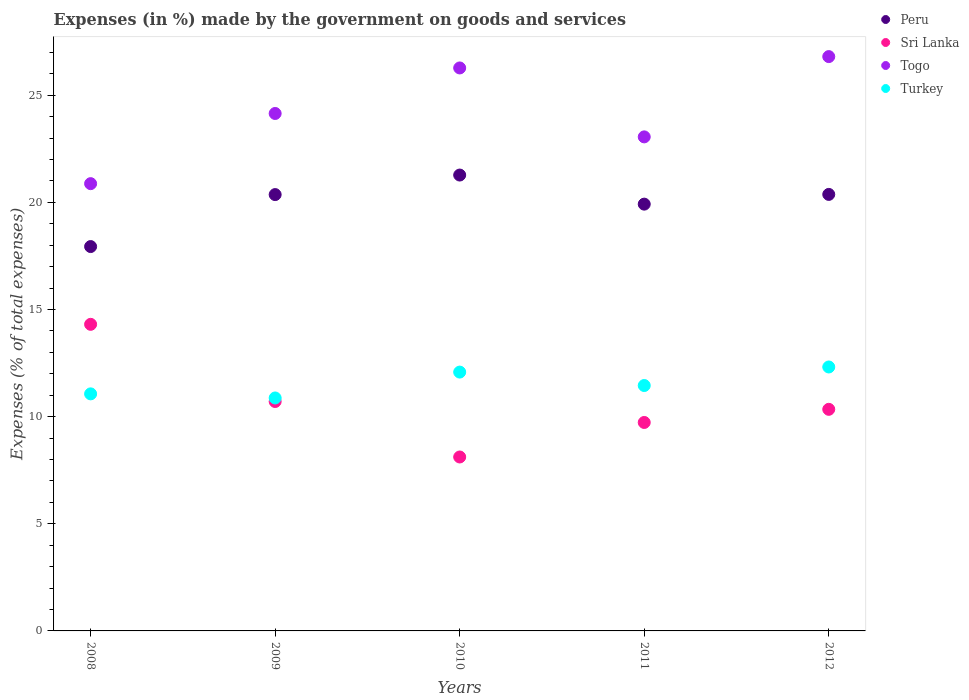What is the percentage of expenses made by the government on goods and services in Sri Lanka in 2009?
Keep it short and to the point. 10.71. Across all years, what is the maximum percentage of expenses made by the government on goods and services in Turkey?
Offer a terse response. 12.32. Across all years, what is the minimum percentage of expenses made by the government on goods and services in Turkey?
Keep it short and to the point. 10.87. In which year was the percentage of expenses made by the government on goods and services in Turkey minimum?
Ensure brevity in your answer.  2009. What is the total percentage of expenses made by the government on goods and services in Turkey in the graph?
Offer a very short reply. 57.79. What is the difference between the percentage of expenses made by the government on goods and services in Peru in 2010 and that in 2011?
Your response must be concise. 1.36. What is the difference between the percentage of expenses made by the government on goods and services in Togo in 2008 and the percentage of expenses made by the government on goods and services in Peru in 2009?
Provide a short and direct response. 0.51. What is the average percentage of expenses made by the government on goods and services in Sri Lanka per year?
Offer a very short reply. 10.64. In the year 2012, what is the difference between the percentage of expenses made by the government on goods and services in Sri Lanka and percentage of expenses made by the government on goods and services in Peru?
Provide a short and direct response. -10.03. In how many years, is the percentage of expenses made by the government on goods and services in Sri Lanka greater than 4 %?
Offer a very short reply. 5. What is the ratio of the percentage of expenses made by the government on goods and services in Turkey in 2009 to that in 2010?
Your response must be concise. 0.9. Is the percentage of expenses made by the government on goods and services in Peru in 2008 less than that in 2011?
Offer a very short reply. Yes. Is the difference between the percentage of expenses made by the government on goods and services in Sri Lanka in 2010 and 2011 greater than the difference between the percentage of expenses made by the government on goods and services in Peru in 2010 and 2011?
Provide a short and direct response. No. What is the difference between the highest and the second highest percentage of expenses made by the government on goods and services in Togo?
Offer a very short reply. 0.53. What is the difference between the highest and the lowest percentage of expenses made by the government on goods and services in Peru?
Your response must be concise. 3.34. Is it the case that in every year, the sum of the percentage of expenses made by the government on goods and services in Togo and percentage of expenses made by the government on goods and services in Peru  is greater than the sum of percentage of expenses made by the government on goods and services in Turkey and percentage of expenses made by the government on goods and services in Sri Lanka?
Your answer should be compact. No. Is the percentage of expenses made by the government on goods and services in Togo strictly greater than the percentage of expenses made by the government on goods and services in Turkey over the years?
Make the answer very short. Yes. How many years are there in the graph?
Your answer should be very brief. 5. How are the legend labels stacked?
Provide a succinct answer. Vertical. What is the title of the graph?
Provide a succinct answer. Expenses (in %) made by the government on goods and services. What is the label or title of the Y-axis?
Give a very brief answer. Expenses (% of total expenses). What is the Expenses (% of total expenses) of Peru in 2008?
Your answer should be very brief. 17.94. What is the Expenses (% of total expenses) in Sri Lanka in 2008?
Give a very brief answer. 14.31. What is the Expenses (% of total expenses) in Togo in 2008?
Keep it short and to the point. 20.87. What is the Expenses (% of total expenses) of Turkey in 2008?
Provide a succinct answer. 11.06. What is the Expenses (% of total expenses) in Peru in 2009?
Make the answer very short. 20.36. What is the Expenses (% of total expenses) in Sri Lanka in 2009?
Keep it short and to the point. 10.71. What is the Expenses (% of total expenses) of Togo in 2009?
Give a very brief answer. 24.15. What is the Expenses (% of total expenses) in Turkey in 2009?
Your response must be concise. 10.87. What is the Expenses (% of total expenses) of Peru in 2010?
Keep it short and to the point. 21.28. What is the Expenses (% of total expenses) in Sri Lanka in 2010?
Provide a succinct answer. 8.12. What is the Expenses (% of total expenses) of Togo in 2010?
Ensure brevity in your answer.  26.27. What is the Expenses (% of total expenses) of Turkey in 2010?
Provide a succinct answer. 12.08. What is the Expenses (% of total expenses) of Peru in 2011?
Your response must be concise. 19.92. What is the Expenses (% of total expenses) in Sri Lanka in 2011?
Keep it short and to the point. 9.73. What is the Expenses (% of total expenses) of Togo in 2011?
Make the answer very short. 23.06. What is the Expenses (% of total expenses) of Turkey in 2011?
Give a very brief answer. 11.45. What is the Expenses (% of total expenses) of Peru in 2012?
Keep it short and to the point. 20.37. What is the Expenses (% of total expenses) in Sri Lanka in 2012?
Provide a succinct answer. 10.34. What is the Expenses (% of total expenses) in Togo in 2012?
Your answer should be very brief. 26.8. What is the Expenses (% of total expenses) of Turkey in 2012?
Your answer should be very brief. 12.32. Across all years, what is the maximum Expenses (% of total expenses) of Peru?
Provide a short and direct response. 21.28. Across all years, what is the maximum Expenses (% of total expenses) in Sri Lanka?
Keep it short and to the point. 14.31. Across all years, what is the maximum Expenses (% of total expenses) in Togo?
Provide a short and direct response. 26.8. Across all years, what is the maximum Expenses (% of total expenses) in Turkey?
Offer a very short reply. 12.32. Across all years, what is the minimum Expenses (% of total expenses) in Peru?
Your answer should be very brief. 17.94. Across all years, what is the minimum Expenses (% of total expenses) of Sri Lanka?
Your response must be concise. 8.12. Across all years, what is the minimum Expenses (% of total expenses) in Togo?
Give a very brief answer. 20.87. Across all years, what is the minimum Expenses (% of total expenses) of Turkey?
Make the answer very short. 10.87. What is the total Expenses (% of total expenses) in Peru in the graph?
Your response must be concise. 99.87. What is the total Expenses (% of total expenses) in Sri Lanka in the graph?
Your answer should be very brief. 53.2. What is the total Expenses (% of total expenses) of Togo in the graph?
Provide a short and direct response. 121.16. What is the total Expenses (% of total expenses) in Turkey in the graph?
Ensure brevity in your answer.  57.79. What is the difference between the Expenses (% of total expenses) of Peru in 2008 and that in 2009?
Give a very brief answer. -2.43. What is the difference between the Expenses (% of total expenses) of Sri Lanka in 2008 and that in 2009?
Your answer should be compact. 3.6. What is the difference between the Expenses (% of total expenses) in Togo in 2008 and that in 2009?
Keep it short and to the point. -3.28. What is the difference between the Expenses (% of total expenses) in Turkey in 2008 and that in 2009?
Keep it short and to the point. 0.19. What is the difference between the Expenses (% of total expenses) of Peru in 2008 and that in 2010?
Offer a very short reply. -3.34. What is the difference between the Expenses (% of total expenses) in Sri Lanka in 2008 and that in 2010?
Offer a terse response. 6.19. What is the difference between the Expenses (% of total expenses) of Togo in 2008 and that in 2010?
Provide a succinct answer. -5.4. What is the difference between the Expenses (% of total expenses) in Turkey in 2008 and that in 2010?
Your response must be concise. -1.02. What is the difference between the Expenses (% of total expenses) of Peru in 2008 and that in 2011?
Give a very brief answer. -1.98. What is the difference between the Expenses (% of total expenses) in Sri Lanka in 2008 and that in 2011?
Provide a short and direct response. 4.58. What is the difference between the Expenses (% of total expenses) in Togo in 2008 and that in 2011?
Keep it short and to the point. -2.18. What is the difference between the Expenses (% of total expenses) in Turkey in 2008 and that in 2011?
Give a very brief answer. -0.39. What is the difference between the Expenses (% of total expenses) of Peru in 2008 and that in 2012?
Your response must be concise. -2.43. What is the difference between the Expenses (% of total expenses) in Sri Lanka in 2008 and that in 2012?
Provide a short and direct response. 3.97. What is the difference between the Expenses (% of total expenses) of Togo in 2008 and that in 2012?
Provide a short and direct response. -5.93. What is the difference between the Expenses (% of total expenses) in Turkey in 2008 and that in 2012?
Offer a terse response. -1.25. What is the difference between the Expenses (% of total expenses) in Peru in 2009 and that in 2010?
Provide a succinct answer. -0.91. What is the difference between the Expenses (% of total expenses) of Sri Lanka in 2009 and that in 2010?
Make the answer very short. 2.59. What is the difference between the Expenses (% of total expenses) in Togo in 2009 and that in 2010?
Offer a very short reply. -2.12. What is the difference between the Expenses (% of total expenses) in Turkey in 2009 and that in 2010?
Your response must be concise. -1.21. What is the difference between the Expenses (% of total expenses) of Peru in 2009 and that in 2011?
Provide a short and direct response. 0.45. What is the difference between the Expenses (% of total expenses) in Sri Lanka in 2009 and that in 2011?
Provide a short and direct response. 0.98. What is the difference between the Expenses (% of total expenses) in Togo in 2009 and that in 2011?
Keep it short and to the point. 1.09. What is the difference between the Expenses (% of total expenses) in Turkey in 2009 and that in 2011?
Give a very brief answer. -0.58. What is the difference between the Expenses (% of total expenses) in Peru in 2009 and that in 2012?
Your response must be concise. -0.01. What is the difference between the Expenses (% of total expenses) of Sri Lanka in 2009 and that in 2012?
Keep it short and to the point. 0.36. What is the difference between the Expenses (% of total expenses) in Togo in 2009 and that in 2012?
Provide a succinct answer. -2.65. What is the difference between the Expenses (% of total expenses) in Turkey in 2009 and that in 2012?
Ensure brevity in your answer.  -1.45. What is the difference between the Expenses (% of total expenses) of Peru in 2010 and that in 2011?
Offer a terse response. 1.36. What is the difference between the Expenses (% of total expenses) of Sri Lanka in 2010 and that in 2011?
Keep it short and to the point. -1.61. What is the difference between the Expenses (% of total expenses) of Togo in 2010 and that in 2011?
Make the answer very short. 3.22. What is the difference between the Expenses (% of total expenses) of Turkey in 2010 and that in 2011?
Make the answer very short. 0.63. What is the difference between the Expenses (% of total expenses) of Peru in 2010 and that in 2012?
Keep it short and to the point. 0.9. What is the difference between the Expenses (% of total expenses) in Sri Lanka in 2010 and that in 2012?
Provide a succinct answer. -2.22. What is the difference between the Expenses (% of total expenses) of Togo in 2010 and that in 2012?
Offer a very short reply. -0.53. What is the difference between the Expenses (% of total expenses) in Turkey in 2010 and that in 2012?
Provide a succinct answer. -0.24. What is the difference between the Expenses (% of total expenses) in Peru in 2011 and that in 2012?
Offer a very short reply. -0.45. What is the difference between the Expenses (% of total expenses) in Sri Lanka in 2011 and that in 2012?
Your response must be concise. -0.61. What is the difference between the Expenses (% of total expenses) of Togo in 2011 and that in 2012?
Your answer should be compact. -3.75. What is the difference between the Expenses (% of total expenses) in Turkey in 2011 and that in 2012?
Give a very brief answer. -0.87. What is the difference between the Expenses (% of total expenses) of Peru in 2008 and the Expenses (% of total expenses) of Sri Lanka in 2009?
Keep it short and to the point. 7.23. What is the difference between the Expenses (% of total expenses) in Peru in 2008 and the Expenses (% of total expenses) in Togo in 2009?
Your response must be concise. -6.21. What is the difference between the Expenses (% of total expenses) in Peru in 2008 and the Expenses (% of total expenses) in Turkey in 2009?
Provide a succinct answer. 7.07. What is the difference between the Expenses (% of total expenses) in Sri Lanka in 2008 and the Expenses (% of total expenses) in Togo in 2009?
Give a very brief answer. -9.84. What is the difference between the Expenses (% of total expenses) of Sri Lanka in 2008 and the Expenses (% of total expenses) of Turkey in 2009?
Provide a short and direct response. 3.44. What is the difference between the Expenses (% of total expenses) in Togo in 2008 and the Expenses (% of total expenses) in Turkey in 2009?
Offer a very short reply. 10. What is the difference between the Expenses (% of total expenses) of Peru in 2008 and the Expenses (% of total expenses) of Sri Lanka in 2010?
Ensure brevity in your answer.  9.82. What is the difference between the Expenses (% of total expenses) of Peru in 2008 and the Expenses (% of total expenses) of Togo in 2010?
Your response must be concise. -8.34. What is the difference between the Expenses (% of total expenses) in Peru in 2008 and the Expenses (% of total expenses) in Turkey in 2010?
Your response must be concise. 5.86. What is the difference between the Expenses (% of total expenses) of Sri Lanka in 2008 and the Expenses (% of total expenses) of Togo in 2010?
Your answer should be very brief. -11.97. What is the difference between the Expenses (% of total expenses) of Sri Lanka in 2008 and the Expenses (% of total expenses) of Turkey in 2010?
Offer a very short reply. 2.23. What is the difference between the Expenses (% of total expenses) of Togo in 2008 and the Expenses (% of total expenses) of Turkey in 2010?
Your answer should be very brief. 8.79. What is the difference between the Expenses (% of total expenses) in Peru in 2008 and the Expenses (% of total expenses) in Sri Lanka in 2011?
Your answer should be compact. 8.21. What is the difference between the Expenses (% of total expenses) in Peru in 2008 and the Expenses (% of total expenses) in Togo in 2011?
Your response must be concise. -5.12. What is the difference between the Expenses (% of total expenses) of Peru in 2008 and the Expenses (% of total expenses) of Turkey in 2011?
Your answer should be very brief. 6.49. What is the difference between the Expenses (% of total expenses) in Sri Lanka in 2008 and the Expenses (% of total expenses) in Togo in 2011?
Give a very brief answer. -8.75. What is the difference between the Expenses (% of total expenses) in Sri Lanka in 2008 and the Expenses (% of total expenses) in Turkey in 2011?
Make the answer very short. 2.86. What is the difference between the Expenses (% of total expenses) of Togo in 2008 and the Expenses (% of total expenses) of Turkey in 2011?
Give a very brief answer. 9.42. What is the difference between the Expenses (% of total expenses) of Peru in 2008 and the Expenses (% of total expenses) of Sri Lanka in 2012?
Your answer should be very brief. 7.6. What is the difference between the Expenses (% of total expenses) of Peru in 2008 and the Expenses (% of total expenses) of Togo in 2012?
Provide a short and direct response. -8.87. What is the difference between the Expenses (% of total expenses) in Peru in 2008 and the Expenses (% of total expenses) in Turkey in 2012?
Ensure brevity in your answer.  5.62. What is the difference between the Expenses (% of total expenses) of Sri Lanka in 2008 and the Expenses (% of total expenses) of Togo in 2012?
Your response must be concise. -12.5. What is the difference between the Expenses (% of total expenses) in Sri Lanka in 2008 and the Expenses (% of total expenses) in Turkey in 2012?
Give a very brief answer. 1.99. What is the difference between the Expenses (% of total expenses) of Togo in 2008 and the Expenses (% of total expenses) of Turkey in 2012?
Your response must be concise. 8.56. What is the difference between the Expenses (% of total expenses) in Peru in 2009 and the Expenses (% of total expenses) in Sri Lanka in 2010?
Ensure brevity in your answer.  12.25. What is the difference between the Expenses (% of total expenses) of Peru in 2009 and the Expenses (% of total expenses) of Togo in 2010?
Give a very brief answer. -5.91. What is the difference between the Expenses (% of total expenses) of Peru in 2009 and the Expenses (% of total expenses) of Turkey in 2010?
Your answer should be compact. 8.28. What is the difference between the Expenses (% of total expenses) of Sri Lanka in 2009 and the Expenses (% of total expenses) of Togo in 2010?
Your response must be concise. -15.57. What is the difference between the Expenses (% of total expenses) of Sri Lanka in 2009 and the Expenses (% of total expenses) of Turkey in 2010?
Give a very brief answer. -1.37. What is the difference between the Expenses (% of total expenses) in Togo in 2009 and the Expenses (% of total expenses) in Turkey in 2010?
Your answer should be compact. 12.07. What is the difference between the Expenses (% of total expenses) of Peru in 2009 and the Expenses (% of total expenses) of Sri Lanka in 2011?
Ensure brevity in your answer.  10.64. What is the difference between the Expenses (% of total expenses) of Peru in 2009 and the Expenses (% of total expenses) of Togo in 2011?
Your response must be concise. -2.69. What is the difference between the Expenses (% of total expenses) in Peru in 2009 and the Expenses (% of total expenses) in Turkey in 2011?
Keep it short and to the point. 8.91. What is the difference between the Expenses (% of total expenses) of Sri Lanka in 2009 and the Expenses (% of total expenses) of Togo in 2011?
Provide a short and direct response. -12.35. What is the difference between the Expenses (% of total expenses) in Sri Lanka in 2009 and the Expenses (% of total expenses) in Turkey in 2011?
Offer a terse response. -0.75. What is the difference between the Expenses (% of total expenses) of Togo in 2009 and the Expenses (% of total expenses) of Turkey in 2011?
Make the answer very short. 12.7. What is the difference between the Expenses (% of total expenses) in Peru in 2009 and the Expenses (% of total expenses) in Sri Lanka in 2012?
Give a very brief answer. 10.02. What is the difference between the Expenses (% of total expenses) of Peru in 2009 and the Expenses (% of total expenses) of Togo in 2012?
Make the answer very short. -6.44. What is the difference between the Expenses (% of total expenses) in Peru in 2009 and the Expenses (% of total expenses) in Turkey in 2012?
Make the answer very short. 8.05. What is the difference between the Expenses (% of total expenses) of Sri Lanka in 2009 and the Expenses (% of total expenses) of Togo in 2012?
Make the answer very short. -16.1. What is the difference between the Expenses (% of total expenses) of Sri Lanka in 2009 and the Expenses (% of total expenses) of Turkey in 2012?
Make the answer very short. -1.61. What is the difference between the Expenses (% of total expenses) of Togo in 2009 and the Expenses (% of total expenses) of Turkey in 2012?
Provide a short and direct response. 11.83. What is the difference between the Expenses (% of total expenses) in Peru in 2010 and the Expenses (% of total expenses) in Sri Lanka in 2011?
Offer a terse response. 11.55. What is the difference between the Expenses (% of total expenses) of Peru in 2010 and the Expenses (% of total expenses) of Togo in 2011?
Offer a very short reply. -1.78. What is the difference between the Expenses (% of total expenses) of Peru in 2010 and the Expenses (% of total expenses) of Turkey in 2011?
Your answer should be very brief. 9.82. What is the difference between the Expenses (% of total expenses) in Sri Lanka in 2010 and the Expenses (% of total expenses) in Togo in 2011?
Provide a short and direct response. -14.94. What is the difference between the Expenses (% of total expenses) in Sri Lanka in 2010 and the Expenses (% of total expenses) in Turkey in 2011?
Provide a succinct answer. -3.34. What is the difference between the Expenses (% of total expenses) of Togo in 2010 and the Expenses (% of total expenses) of Turkey in 2011?
Give a very brief answer. 14.82. What is the difference between the Expenses (% of total expenses) of Peru in 2010 and the Expenses (% of total expenses) of Sri Lanka in 2012?
Your answer should be very brief. 10.93. What is the difference between the Expenses (% of total expenses) in Peru in 2010 and the Expenses (% of total expenses) in Togo in 2012?
Offer a terse response. -5.53. What is the difference between the Expenses (% of total expenses) of Peru in 2010 and the Expenses (% of total expenses) of Turkey in 2012?
Ensure brevity in your answer.  8.96. What is the difference between the Expenses (% of total expenses) in Sri Lanka in 2010 and the Expenses (% of total expenses) in Togo in 2012?
Your answer should be very brief. -18.69. What is the difference between the Expenses (% of total expenses) in Sri Lanka in 2010 and the Expenses (% of total expenses) in Turkey in 2012?
Provide a short and direct response. -4.2. What is the difference between the Expenses (% of total expenses) in Togo in 2010 and the Expenses (% of total expenses) in Turkey in 2012?
Your response must be concise. 13.96. What is the difference between the Expenses (% of total expenses) in Peru in 2011 and the Expenses (% of total expenses) in Sri Lanka in 2012?
Your answer should be very brief. 9.58. What is the difference between the Expenses (% of total expenses) in Peru in 2011 and the Expenses (% of total expenses) in Togo in 2012?
Provide a short and direct response. -6.89. What is the difference between the Expenses (% of total expenses) of Sri Lanka in 2011 and the Expenses (% of total expenses) of Togo in 2012?
Keep it short and to the point. -17.08. What is the difference between the Expenses (% of total expenses) in Sri Lanka in 2011 and the Expenses (% of total expenses) in Turkey in 2012?
Your answer should be compact. -2.59. What is the difference between the Expenses (% of total expenses) of Togo in 2011 and the Expenses (% of total expenses) of Turkey in 2012?
Your answer should be very brief. 10.74. What is the average Expenses (% of total expenses) in Peru per year?
Your answer should be compact. 19.97. What is the average Expenses (% of total expenses) in Sri Lanka per year?
Offer a very short reply. 10.64. What is the average Expenses (% of total expenses) of Togo per year?
Make the answer very short. 24.23. What is the average Expenses (% of total expenses) in Turkey per year?
Your answer should be very brief. 11.56. In the year 2008, what is the difference between the Expenses (% of total expenses) in Peru and Expenses (% of total expenses) in Sri Lanka?
Your answer should be very brief. 3.63. In the year 2008, what is the difference between the Expenses (% of total expenses) in Peru and Expenses (% of total expenses) in Togo?
Keep it short and to the point. -2.94. In the year 2008, what is the difference between the Expenses (% of total expenses) in Peru and Expenses (% of total expenses) in Turkey?
Offer a terse response. 6.87. In the year 2008, what is the difference between the Expenses (% of total expenses) in Sri Lanka and Expenses (% of total expenses) in Togo?
Provide a succinct answer. -6.57. In the year 2008, what is the difference between the Expenses (% of total expenses) in Sri Lanka and Expenses (% of total expenses) in Turkey?
Offer a terse response. 3.25. In the year 2008, what is the difference between the Expenses (% of total expenses) in Togo and Expenses (% of total expenses) in Turkey?
Offer a very short reply. 9.81. In the year 2009, what is the difference between the Expenses (% of total expenses) of Peru and Expenses (% of total expenses) of Sri Lanka?
Provide a succinct answer. 9.66. In the year 2009, what is the difference between the Expenses (% of total expenses) in Peru and Expenses (% of total expenses) in Togo?
Your answer should be very brief. -3.79. In the year 2009, what is the difference between the Expenses (% of total expenses) in Peru and Expenses (% of total expenses) in Turkey?
Ensure brevity in your answer.  9.49. In the year 2009, what is the difference between the Expenses (% of total expenses) of Sri Lanka and Expenses (% of total expenses) of Togo?
Provide a short and direct response. -13.44. In the year 2009, what is the difference between the Expenses (% of total expenses) in Sri Lanka and Expenses (% of total expenses) in Turkey?
Your response must be concise. -0.17. In the year 2009, what is the difference between the Expenses (% of total expenses) of Togo and Expenses (% of total expenses) of Turkey?
Give a very brief answer. 13.28. In the year 2010, what is the difference between the Expenses (% of total expenses) in Peru and Expenses (% of total expenses) in Sri Lanka?
Provide a succinct answer. 13.16. In the year 2010, what is the difference between the Expenses (% of total expenses) of Peru and Expenses (% of total expenses) of Togo?
Your answer should be compact. -5. In the year 2010, what is the difference between the Expenses (% of total expenses) in Peru and Expenses (% of total expenses) in Turkey?
Your response must be concise. 9.2. In the year 2010, what is the difference between the Expenses (% of total expenses) of Sri Lanka and Expenses (% of total expenses) of Togo?
Offer a terse response. -18.16. In the year 2010, what is the difference between the Expenses (% of total expenses) in Sri Lanka and Expenses (% of total expenses) in Turkey?
Provide a short and direct response. -3.96. In the year 2010, what is the difference between the Expenses (% of total expenses) in Togo and Expenses (% of total expenses) in Turkey?
Your response must be concise. 14.19. In the year 2011, what is the difference between the Expenses (% of total expenses) of Peru and Expenses (% of total expenses) of Sri Lanka?
Make the answer very short. 10.19. In the year 2011, what is the difference between the Expenses (% of total expenses) in Peru and Expenses (% of total expenses) in Togo?
Give a very brief answer. -3.14. In the year 2011, what is the difference between the Expenses (% of total expenses) in Peru and Expenses (% of total expenses) in Turkey?
Make the answer very short. 8.47. In the year 2011, what is the difference between the Expenses (% of total expenses) of Sri Lanka and Expenses (% of total expenses) of Togo?
Keep it short and to the point. -13.33. In the year 2011, what is the difference between the Expenses (% of total expenses) of Sri Lanka and Expenses (% of total expenses) of Turkey?
Offer a terse response. -1.72. In the year 2011, what is the difference between the Expenses (% of total expenses) in Togo and Expenses (% of total expenses) in Turkey?
Offer a very short reply. 11.6. In the year 2012, what is the difference between the Expenses (% of total expenses) in Peru and Expenses (% of total expenses) in Sri Lanka?
Make the answer very short. 10.03. In the year 2012, what is the difference between the Expenses (% of total expenses) in Peru and Expenses (% of total expenses) in Togo?
Give a very brief answer. -6.43. In the year 2012, what is the difference between the Expenses (% of total expenses) in Peru and Expenses (% of total expenses) in Turkey?
Offer a terse response. 8.05. In the year 2012, what is the difference between the Expenses (% of total expenses) in Sri Lanka and Expenses (% of total expenses) in Togo?
Offer a terse response. -16.46. In the year 2012, what is the difference between the Expenses (% of total expenses) in Sri Lanka and Expenses (% of total expenses) in Turkey?
Provide a short and direct response. -1.98. In the year 2012, what is the difference between the Expenses (% of total expenses) in Togo and Expenses (% of total expenses) in Turkey?
Offer a terse response. 14.49. What is the ratio of the Expenses (% of total expenses) of Peru in 2008 to that in 2009?
Provide a short and direct response. 0.88. What is the ratio of the Expenses (% of total expenses) in Sri Lanka in 2008 to that in 2009?
Your answer should be compact. 1.34. What is the ratio of the Expenses (% of total expenses) in Togo in 2008 to that in 2009?
Provide a short and direct response. 0.86. What is the ratio of the Expenses (% of total expenses) in Turkey in 2008 to that in 2009?
Give a very brief answer. 1.02. What is the ratio of the Expenses (% of total expenses) of Peru in 2008 to that in 2010?
Provide a short and direct response. 0.84. What is the ratio of the Expenses (% of total expenses) in Sri Lanka in 2008 to that in 2010?
Offer a terse response. 1.76. What is the ratio of the Expenses (% of total expenses) of Togo in 2008 to that in 2010?
Ensure brevity in your answer.  0.79. What is the ratio of the Expenses (% of total expenses) in Turkey in 2008 to that in 2010?
Keep it short and to the point. 0.92. What is the ratio of the Expenses (% of total expenses) of Peru in 2008 to that in 2011?
Your answer should be compact. 0.9. What is the ratio of the Expenses (% of total expenses) in Sri Lanka in 2008 to that in 2011?
Offer a terse response. 1.47. What is the ratio of the Expenses (% of total expenses) in Togo in 2008 to that in 2011?
Your answer should be compact. 0.91. What is the ratio of the Expenses (% of total expenses) of Peru in 2008 to that in 2012?
Your answer should be very brief. 0.88. What is the ratio of the Expenses (% of total expenses) of Sri Lanka in 2008 to that in 2012?
Make the answer very short. 1.38. What is the ratio of the Expenses (% of total expenses) in Togo in 2008 to that in 2012?
Your response must be concise. 0.78. What is the ratio of the Expenses (% of total expenses) in Turkey in 2008 to that in 2012?
Keep it short and to the point. 0.9. What is the ratio of the Expenses (% of total expenses) in Peru in 2009 to that in 2010?
Provide a short and direct response. 0.96. What is the ratio of the Expenses (% of total expenses) in Sri Lanka in 2009 to that in 2010?
Offer a very short reply. 1.32. What is the ratio of the Expenses (% of total expenses) in Togo in 2009 to that in 2010?
Offer a terse response. 0.92. What is the ratio of the Expenses (% of total expenses) of Turkey in 2009 to that in 2010?
Keep it short and to the point. 0.9. What is the ratio of the Expenses (% of total expenses) of Peru in 2009 to that in 2011?
Keep it short and to the point. 1.02. What is the ratio of the Expenses (% of total expenses) in Sri Lanka in 2009 to that in 2011?
Provide a succinct answer. 1.1. What is the ratio of the Expenses (% of total expenses) of Togo in 2009 to that in 2011?
Provide a succinct answer. 1.05. What is the ratio of the Expenses (% of total expenses) in Turkey in 2009 to that in 2011?
Your answer should be very brief. 0.95. What is the ratio of the Expenses (% of total expenses) of Peru in 2009 to that in 2012?
Ensure brevity in your answer.  1. What is the ratio of the Expenses (% of total expenses) of Sri Lanka in 2009 to that in 2012?
Provide a succinct answer. 1.04. What is the ratio of the Expenses (% of total expenses) in Togo in 2009 to that in 2012?
Ensure brevity in your answer.  0.9. What is the ratio of the Expenses (% of total expenses) of Turkey in 2009 to that in 2012?
Make the answer very short. 0.88. What is the ratio of the Expenses (% of total expenses) of Peru in 2010 to that in 2011?
Ensure brevity in your answer.  1.07. What is the ratio of the Expenses (% of total expenses) of Sri Lanka in 2010 to that in 2011?
Your answer should be very brief. 0.83. What is the ratio of the Expenses (% of total expenses) in Togo in 2010 to that in 2011?
Keep it short and to the point. 1.14. What is the ratio of the Expenses (% of total expenses) in Turkey in 2010 to that in 2011?
Keep it short and to the point. 1.05. What is the ratio of the Expenses (% of total expenses) in Peru in 2010 to that in 2012?
Ensure brevity in your answer.  1.04. What is the ratio of the Expenses (% of total expenses) of Sri Lanka in 2010 to that in 2012?
Offer a terse response. 0.78. What is the ratio of the Expenses (% of total expenses) in Togo in 2010 to that in 2012?
Provide a short and direct response. 0.98. What is the ratio of the Expenses (% of total expenses) of Turkey in 2010 to that in 2012?
Keep it short and to the point. 0.98. What is the ratio of the Expenses (% of total expenses) in Peru in 2011 to that in 2012?
Offer a terse response. 0.98. What is the ratio of the Expenses (% of total expenses) in Sri Lanka in 2011 to that in 2012?
Offer a terse response. 0.94. What is the ratio of the Expenses (% of total expenses) of Togo in 2011 to that in 2012?
Provide a succinct answer. 0.86. What is the ratio of the Expenses (% of total expenses) in Turkey in 2011 to that in 2012?
Provide a short and direct response. 0.93. What is the difference between the highest and the second highest Expenses (% of total expenses) of Peru?
Ensure brevity in your answer.  0.9. What is the difference between the highest and the second highest Expenses (% of total expenses) in Sri Lanka?
Your answer should be compact. 3.6. What is the difference between the highest and the second highest Expenses (% of total expenses) in Togo?
Ensure brevity in your answer.  0.53. What is the difference between the highest and the second highest Expenses (% of total expenses) in Turkey?
Your answer should be very brief. 0.24. What is the difference between the highest and the lowest Expenses (% of total expenses) of Peru?
Provide a short and direct response. 3.34. What is the difference between the highest and the lowest Expenses (% of total expenses) of Sri Lanka?
Your answer should be compact. 6.19. What is the difference between the highest and the lowest Expenses (% of total expenses) of Togo?
Your response must be concise. 5.93. What is the difference between the highest and the lowest Expenses (% of total expenses) in Turkey?
Give a very brief answer. 1.45. 